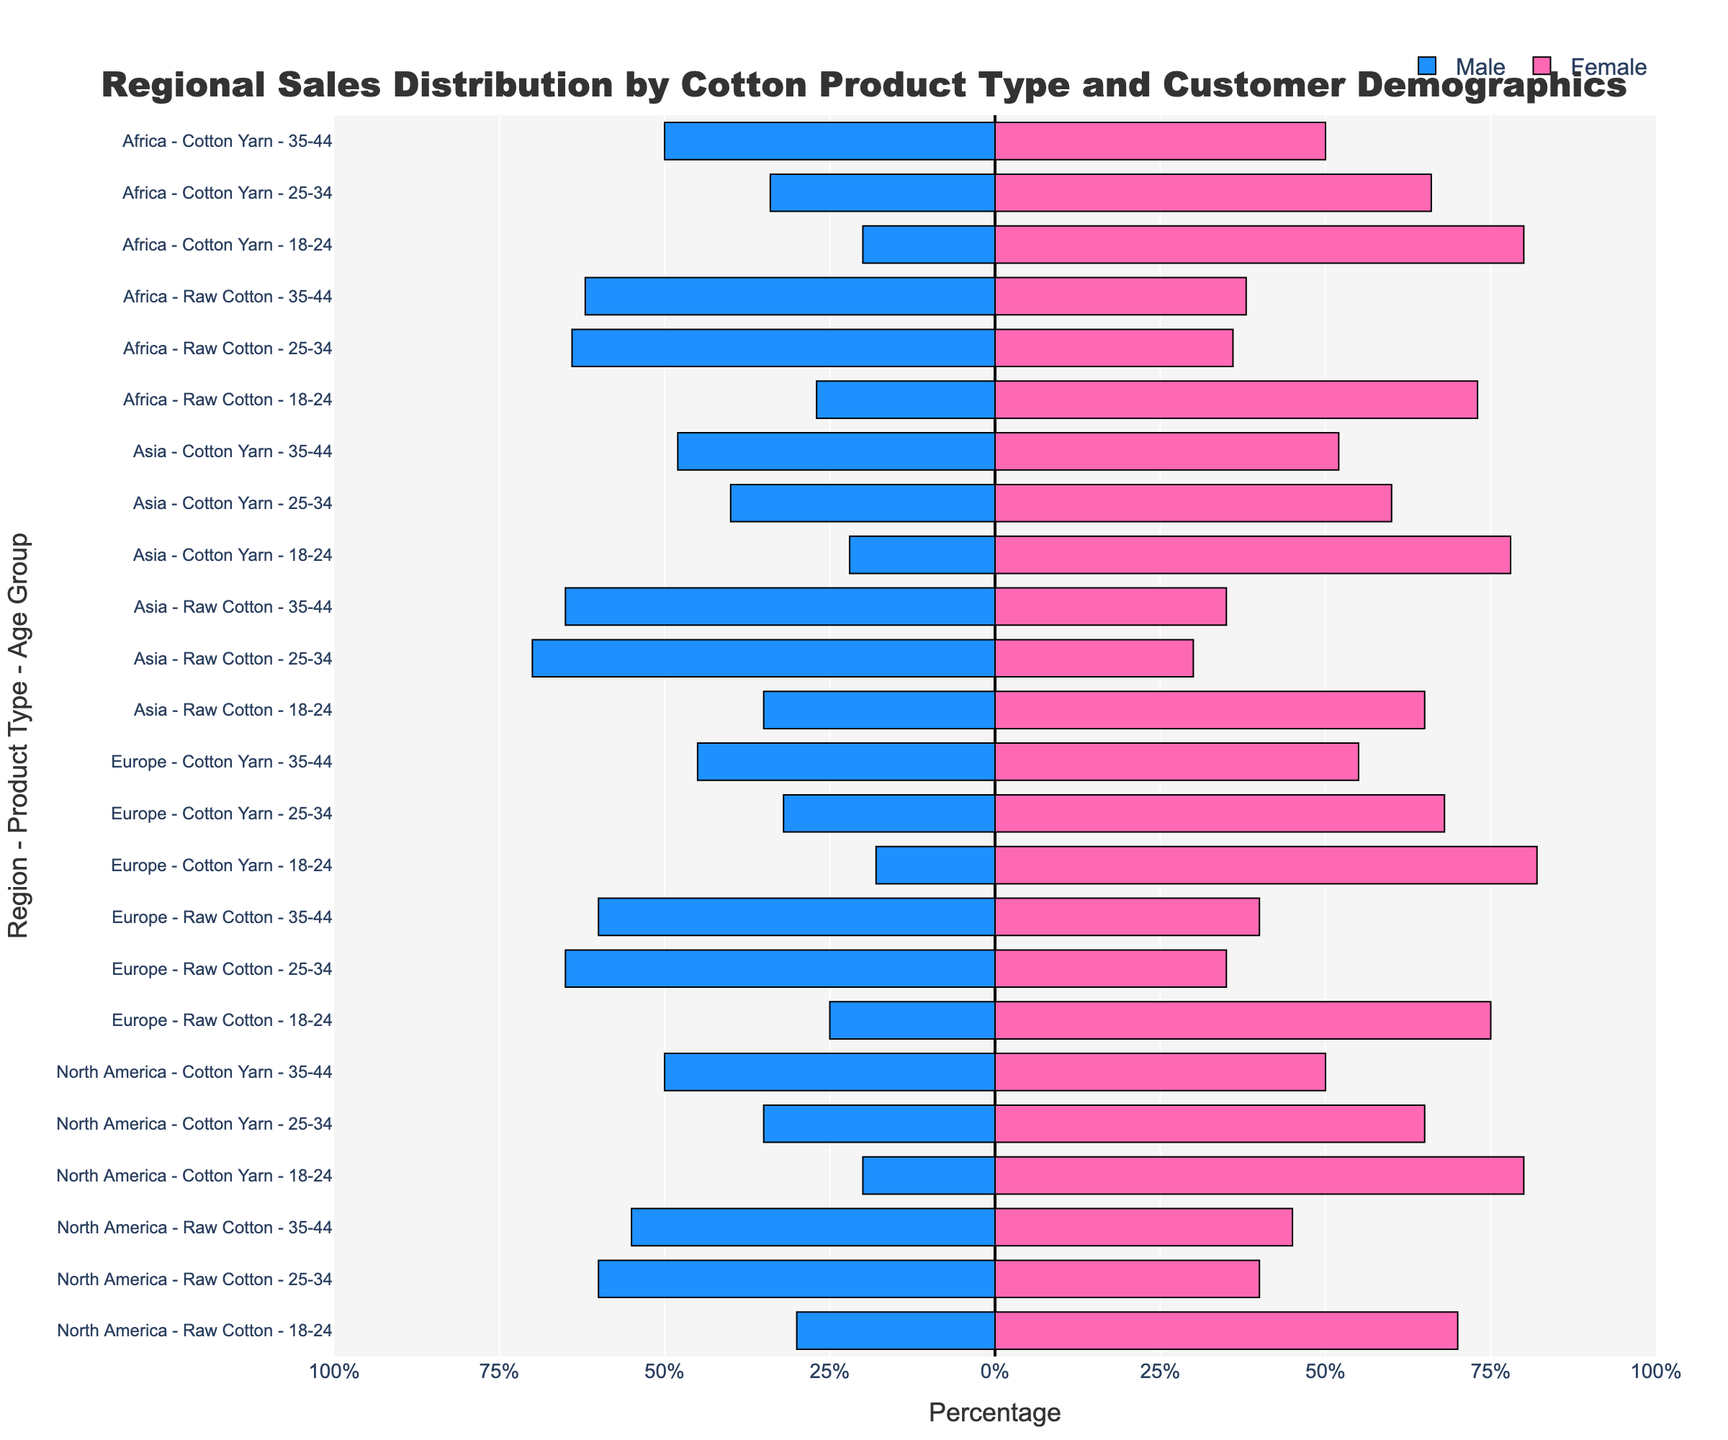Which region has the highest percentage of female customers for Raw Cotton in the 25-34 age group? To find the region with the highest percentage of female customers for Raw Cotton in the 25-34 age group, we look at the respective percentage bars on the chart. For North America, it’s 40%; for Europe, it’s 35%; for Asia, it’s 30%; and for Africa, it’s 36%. The highest value among these is 40%, which is for North America.
Answer: North America Which product type and age group combination shows equal distribution between male and female customers in Africa? In Africa, we need to look for bars where the percentages for male and female customers are equal. For Raw Cotton, none of the age groups show equal distribution. For Cotton Yarn, the 35-44 age group has both male and female at 50%.
Answer: Cotton Yarn, 35-44 What is the average percentage of female customers for Raw Cotton across all age groups in North America? To calculate the average percentage of female customers for Raw Cotton in North America, we sum the percentages for all three age groups and divide by 3. (70% + 40% + 45%) / 3 = 155% / 3 ≈ 51.67%
Answer: 51.67% Is the percentage of female customers higher for Cotton Yarn in the 18-24 age group in Asia compared to Europe? We compare the percentage bars for Cotton Yarn in the 18-24 age group between Asia and Europe. The chart shows 78% for Asia and 82% for Europe, indicating that Europe has a higher percentage.
Answer: No Which age group has the highest percentage of male customers for Raw Cotton in Asia? We examine the bars for Raw Cotton in Asia across all three age groups. The 18-24 age group has 35%, the 25-34 age group has 70%, and the 35-44 age group has 65%. The highest percentage is 70% in the 25-34 age group.
Answer: 25-34 What is the difference in the percentage of female customers for Cotton Yarn between the 25-34 age group and the 35-44 age group in North America? We examine Cotton Yarn in North America and compare the female percentages for the 25-34 and 35-44 age groups. The 25-34 age group has 65%, and the 35-44 age group has 50%. The difference is 65% - 50% = 15%.
Answer: 15% Which age group in Europe has the smallest gap in percentage between male and female customers for Raw Cotton? We look at the difference between male and female percentages in the Raw Cotton category in Europe. For 18-24, the gap is 75% - 25% = 50%; for 25-34, the gap is 65% - 35% = 30%; for 35-44, the gap is 60% - 40% = 20%. The smallest gap is 20% in the 35-44 age group.
Answer: 35-44 How does the percentage of male customers for Cotton Yarn in the 18-24 age group compare between North America and Africa? We examine the male percentage bars for Cotton Yarn in the 18-24 age group in both regions. North America has 20%, while Africa has 20%. The percentages are identical.
Answer: Equal 